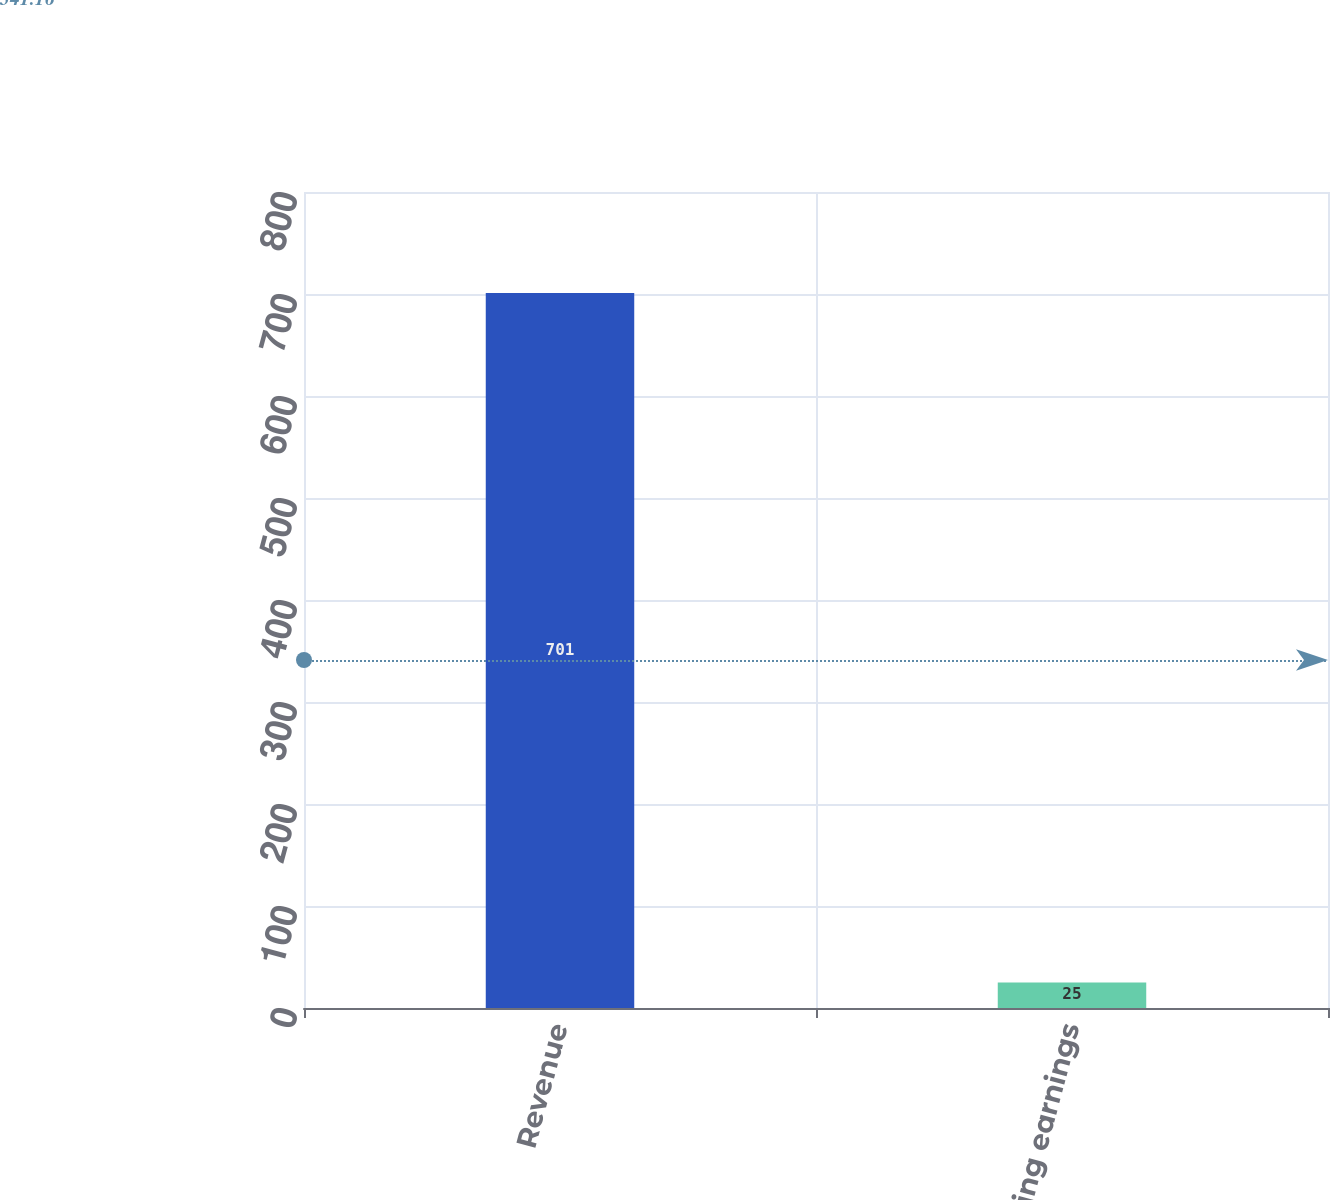<chart> <loc_0><loc_0><loc_500><loc_500><bar_chart><fcel>Revenue<fcel>Operating earnings<nl><fcel>701<fcel>25<nl></chart> 